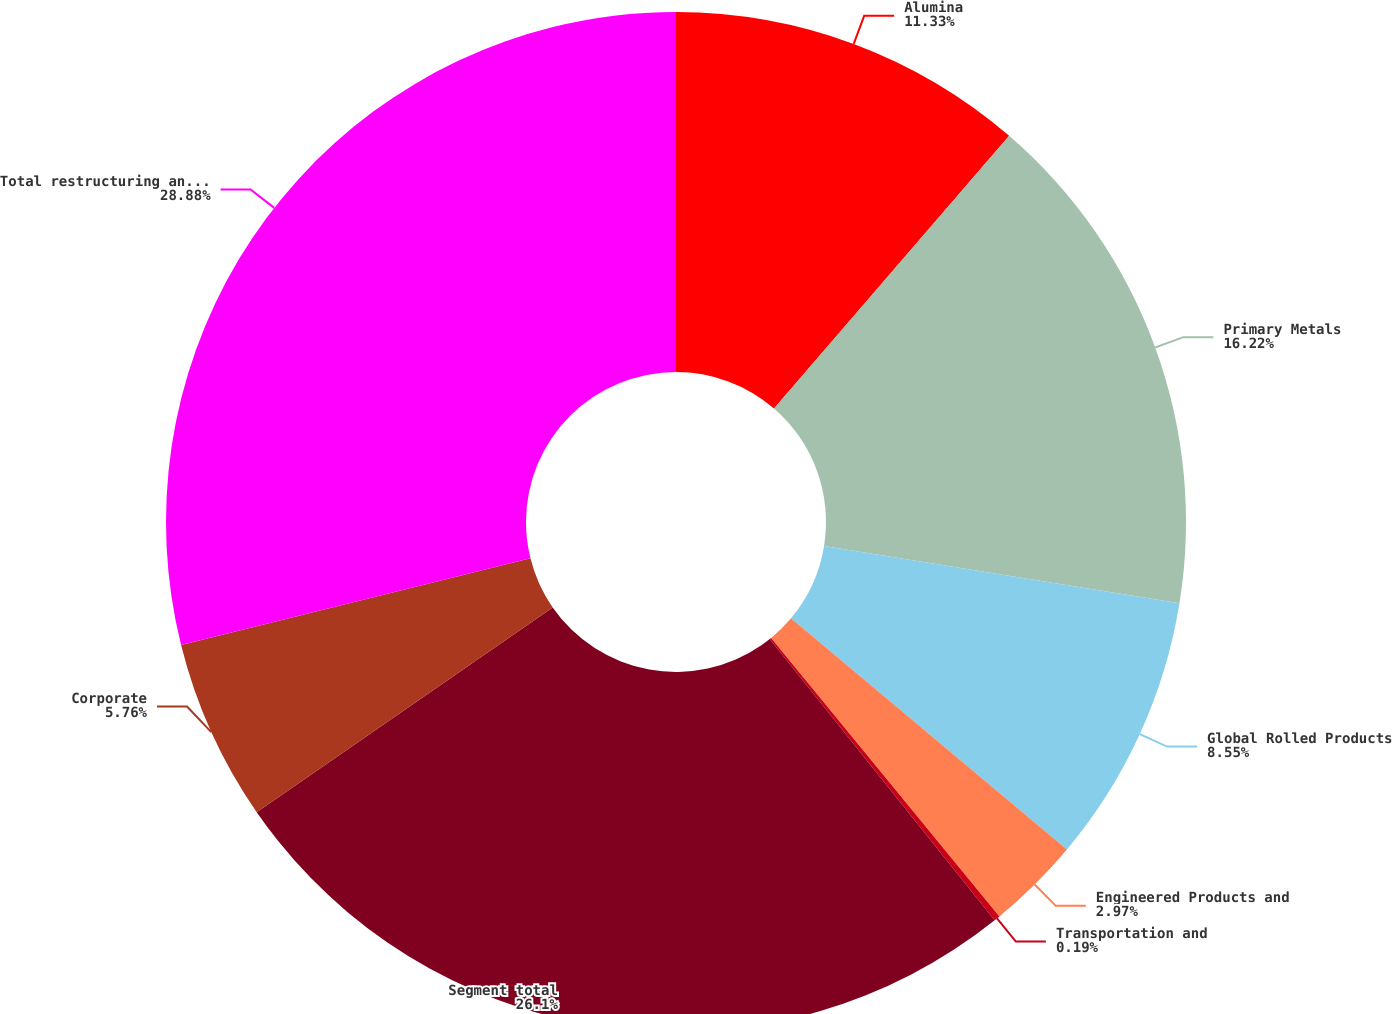Convert chart to OTSL. <chart><loc_0><loc_0><loc_500><loc_500><pie_chart><fcel>Alumina<fcel>Primary Metals<fcel>Global Rolled Products<fcel>Engineered Products and<fcel>Transportation and<fcel>Segment total<fcel>Corporate<fcel>Total restructuring and other<nl><fcel>11.33%<fcel>16.22%<fcel>8.55%<fcel>2.97%<fcel>0.19%<fcel>26.1%<fcel>5.76%<fcel>28.88%<nl></chart> 